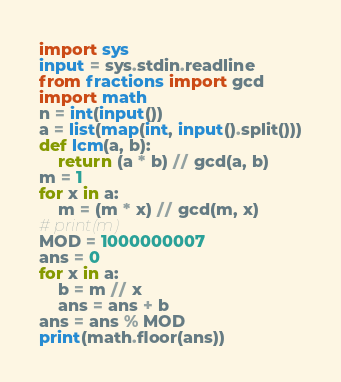Convert code to text. <code><loc_0><loc_0><loc_500><loc_500><_Python_>import sys
input = sys.stdin.readline
from fractions import gcd
import math
n = int(input())
a = list(map(int, input().split()))
def lcm(a, b):
    return (a * b) // gcd(a, b)
m = 1
for x in a:
    m = (m * x) // gcd(m, x)
# print(m)
MOD = 1000000007
ans = 0
for x in a:
    b = m // x
    ans = ans + b
ans = ans % MOD
print(math.floor(ans))
</code> 